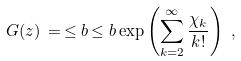Convert formula to latex. <formula><loc_0><loc_0><loc_500><loc_500>G ( z ) \, = \, \leq b { \, \leq b { \, \exp \left ( \sum _ { k = 2 } ^ { \infty } \frac { \chi _ { k } } { k ! } \right ) \, } \, } \, ,</formula> 